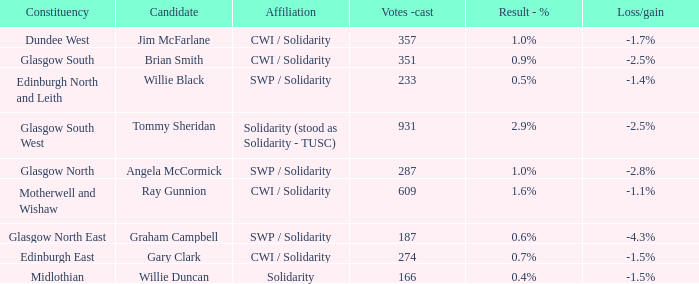What was the number of votes cast in the midlothian constituency? 166.0. 